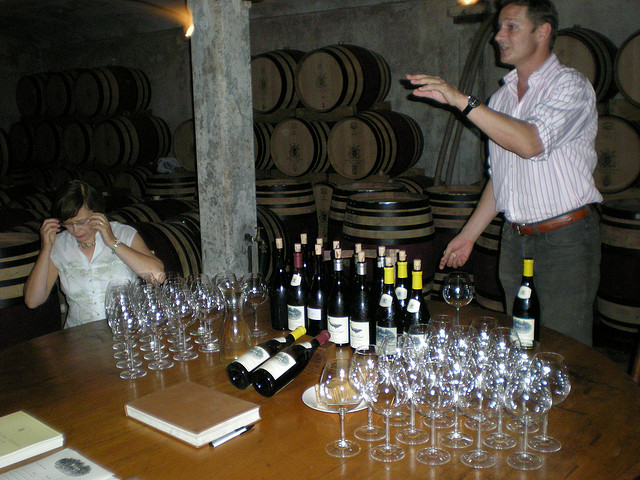Is there anything in the image that can provide hints about the location of this winery? The image presents a cellar with traditional oak barrels and a selection of wines which often indicates aging processes used in European vineyards. The vaulted stone ceilings and the rustic decor of the room correlate with architectural styles commonly found in regions like Burgundy or Tuscany, known for their robust winemaking traditions. Moreover, the presentation style, with numerous glasses laid out for a wine tasting, suggests a winery accustomed to hosting guests, possibly indicating a popular wine tourism destination. While these observations suggest a European setting, the exact location remains unidentified without clear geographical markers or labels in the image. 